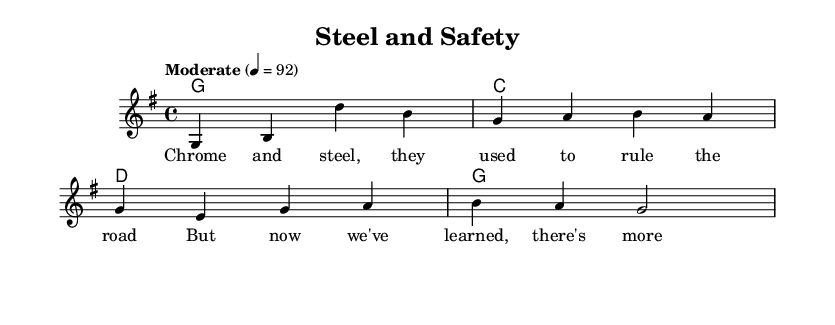What is the key signature of this music? The key signature shown in the sheet music indicates that the piece is in G major, which has one sharp (F#).
Answer: G major What is the time signature of this music? The time signature is found at the beginning of the staff, showing a 4 over 4, which means there are four beats in each measure.
Answer: 4/4 What is the tempo marking of this piece? The tempo marking is specified as "Moderate" with a metronome marking of 92, meaning it should be played at a moderate speed.
Answer: Moderate 92 How many measures are in the music? By counting the measures in the score provided, there are a total of four measures shown in the melody section.
Answer: 4 What type of chords are used in the harmonies? The chords are basic triads specified in chord mode: G, C, and D, which are typical of country music harmonies.
Answer: G, C, D What is the lyrical theme described in the verse? The lyrics suggest a nostalgic reflection on the transition from classic cars (chrome and steel) to modern safety standards, emphasizing a sense of evolution in vehicle technology.
Answer: Nostalgia for classic cars How does the song relate to vehicle safety? The song draws a connection between the past dominance of classic cars and the present understanding of the importance of safety features in modern vehicles, which is a key theme in vehicle safety discussions.
Answer: Evolution of safety 